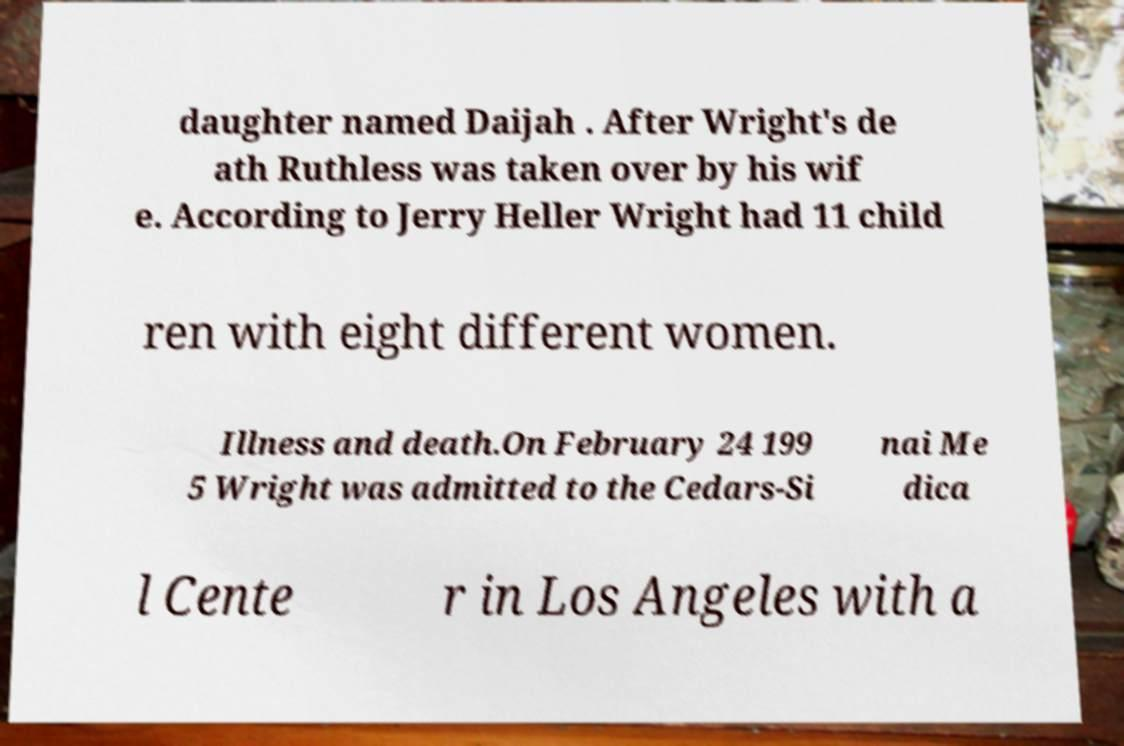Please identify and transcribe the text found in this image. daughter named Daijah . After Wright's de ath Ruthless was taken over by his wif e. According to Jerry Heller Wright had 11 child ren with eight different women. Illness and death.On February 24 199 5 Wright was admitted to the Cedars-Si nai Me dica l Cente r in Los Angeles with a 